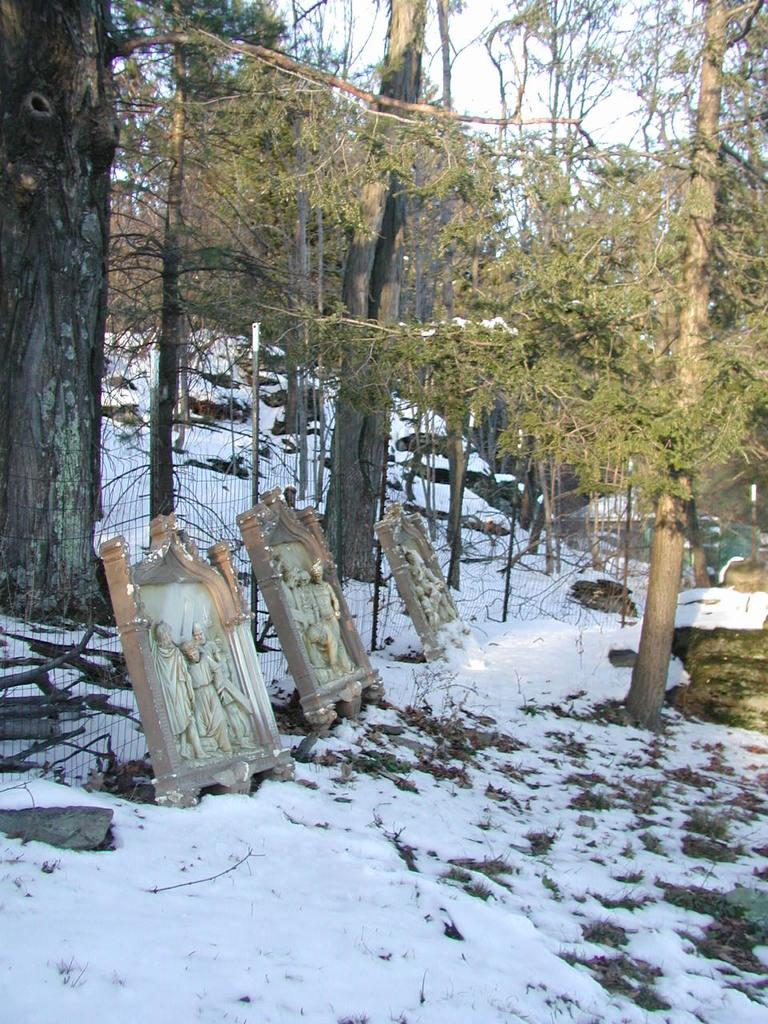What can be found on the ground in the image? There are sculptures on the ground in the image. What type of barrier is present in the image? There is a fence in the image. What is the weather like in the image? There is snow in the image, indicating a cold or wintry environment. What type of vegetation is present in the image? There are trees in the image. What objects are present in the image? There are sticks in the image. What is visible in the background of the image? The sky is visible in the background of the image. What type of polish is being applied to the sculptures in the image? There is no indication in the image that any polish is being applied to the sculptures. Can you hear the sound of thunder in the image? There is no sound present in the image, so it is not possible to determine if thunder can be heard. 